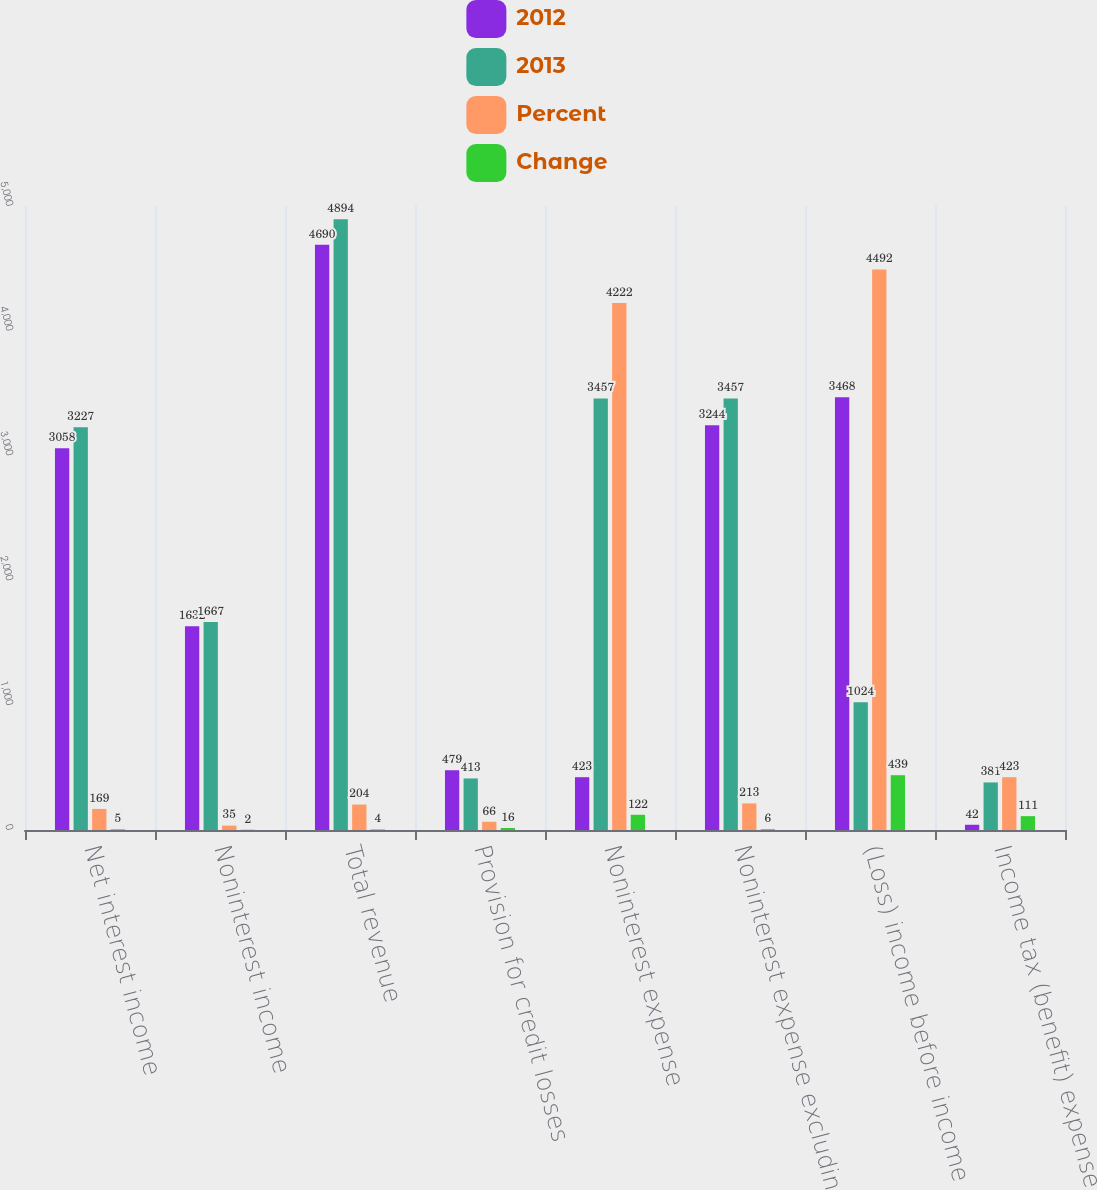<chart> <loc_0><loc_0><loc_500><loc_500><stacked_bar_chart><ecel><fcel>Net interest income<fcel>Noninterest income<fcel>Total revenue<fcel>Provision for credit losses<fcel>Noninterest expense<fcel>Noninterest expense excluding<fcel>(Loss) income before income<fcel>Income tax (benefit) expense<nl><fcel>2012<fcel>3058<fcel>1632<fcel>4690<fcel>479<fcel>423<fcel>3244<fcel>3468<fcel>42<nl><fcel>2013<fcel>3227<fcel>1667<fcel>4894<fcel>413<fcel>3457<fcel>3457<fcel>1024<fcel>381<nl><fcel>Percent<fcel>169<fcel>35<fcel>204<fcel>66<fcel>4222<fcel>213<fcel>4492<fcel>423<nl><fcel>Change<fcel>5<fcel>2<fcel>4<fcel>16<fcel>122<fcel>6<fcel>439<fcel>111<nl></chart> 